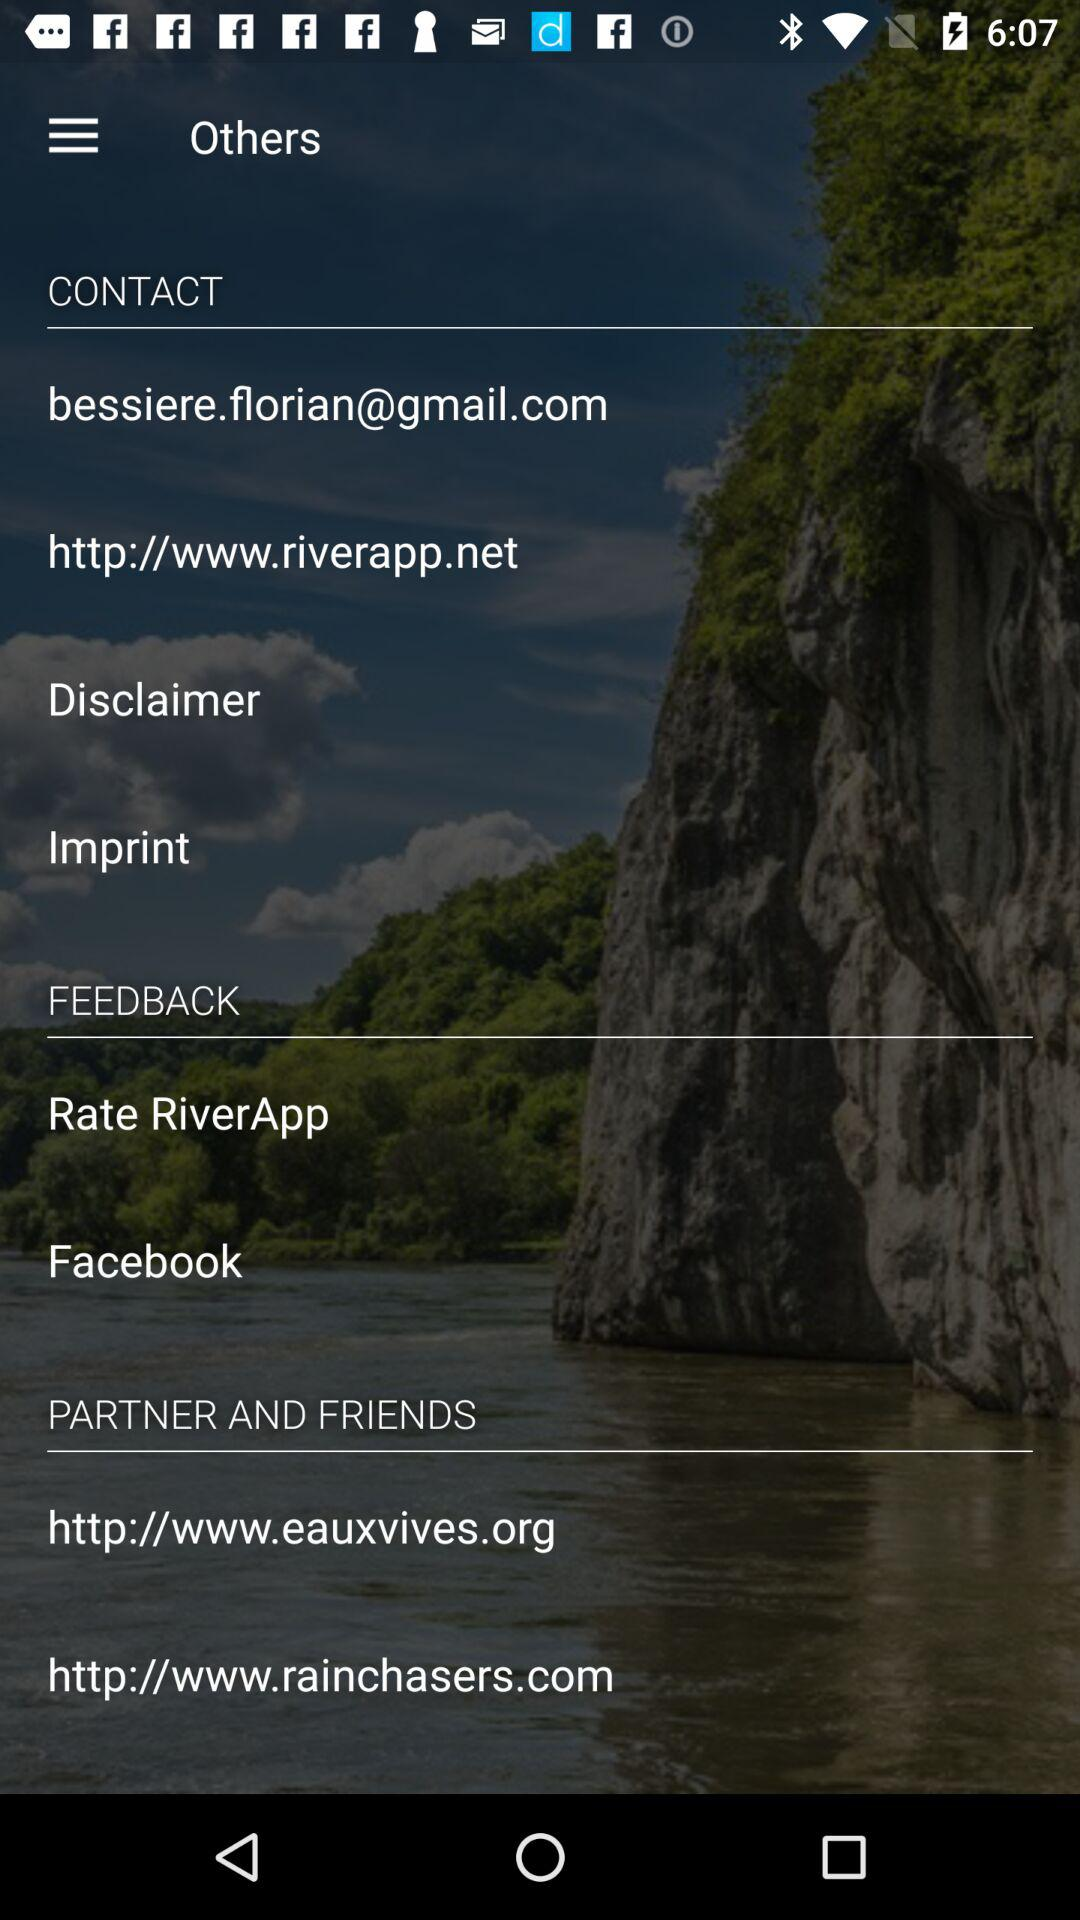What is the contact link? The contact link is http://www.riverapp.net. 